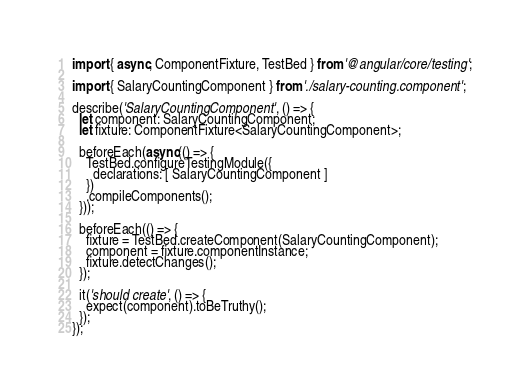Convert code to text. <code><loc_0><loc_0><loc_500><loc_500><_TypeScript_>import { async, ComponentFixture, TestBed } from '@angular/core/testing';

import { SalaryCountingComponent } from './salary-counting.component';

describe('SalaryCountingComponent', () => {
  let component: SalaryCountingComponent;
  let fixture: ComponentFixture<SalaryCountingComponent>;

  beforeEach(async(() => {
    TestBed.configureTestingModule({
      declarations: [ SalaryCountingComponent ]
    })
    .compileComponents();
  }));

  beforeEach(() => {
    fixture = TestBed.createComponent(SalaryCountingComponent);
    component = fixture.componentInstance;
    fixture.detectChanges();
  });

  it('should create', () => {
    expect(component).toBeTruthy();
  });
});
</code> 